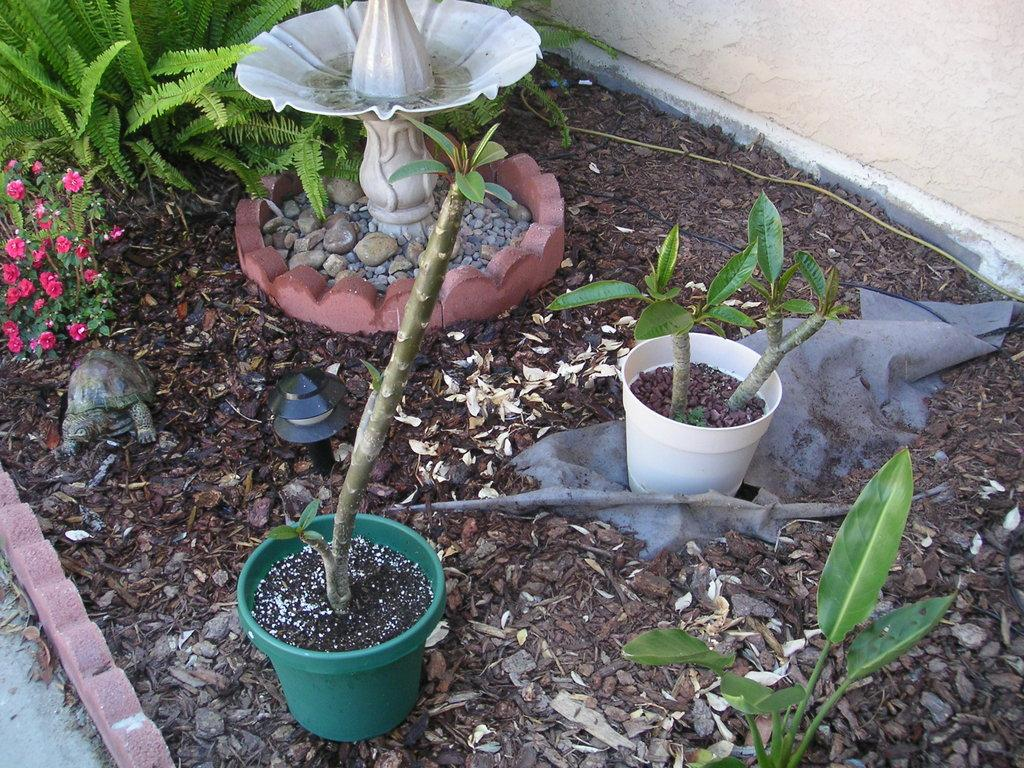What is the main feature in the center of the image? There is a fountain in the center of the image. What can be seen in the top left corner of the image? There are plants and flowers in the top left corner of the image. Are there any plants visible elsewhere in the image? Yes, there are plants visible at the bottom of the image. What is located in the top right corner of the image? There is a wall in the top right corner of the image. What type of degree does the cat have in the image? There is no cat present in the image, and therefore no degree can be attributed to it. 